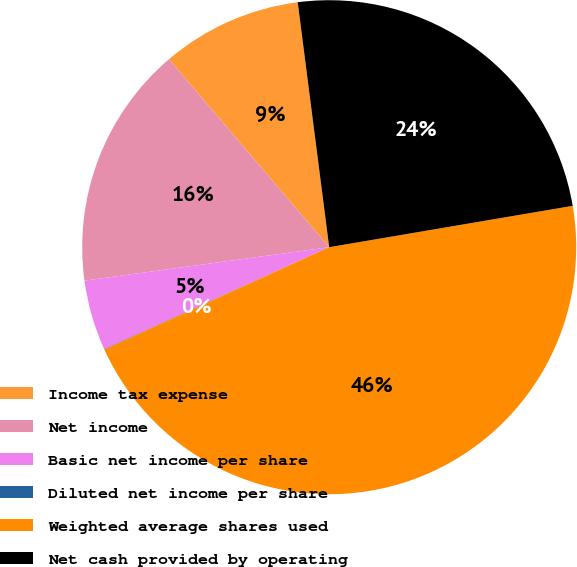<chart> <loc_0><loc_0><loc_500><loc_500><pie_chart><fcel>Income tax expense<fcel>Net income<fcel>Basic net income per share<fcel>Diluted net income per share<fcel>Weighted average shares used<fcel>Net cash provided by operating<nl><fcel>9.2%<fcel>15.93%<fcel>4.61%<fcel>0.03%<fcel>45.88%<fcel>24.36%<nl></chart> 